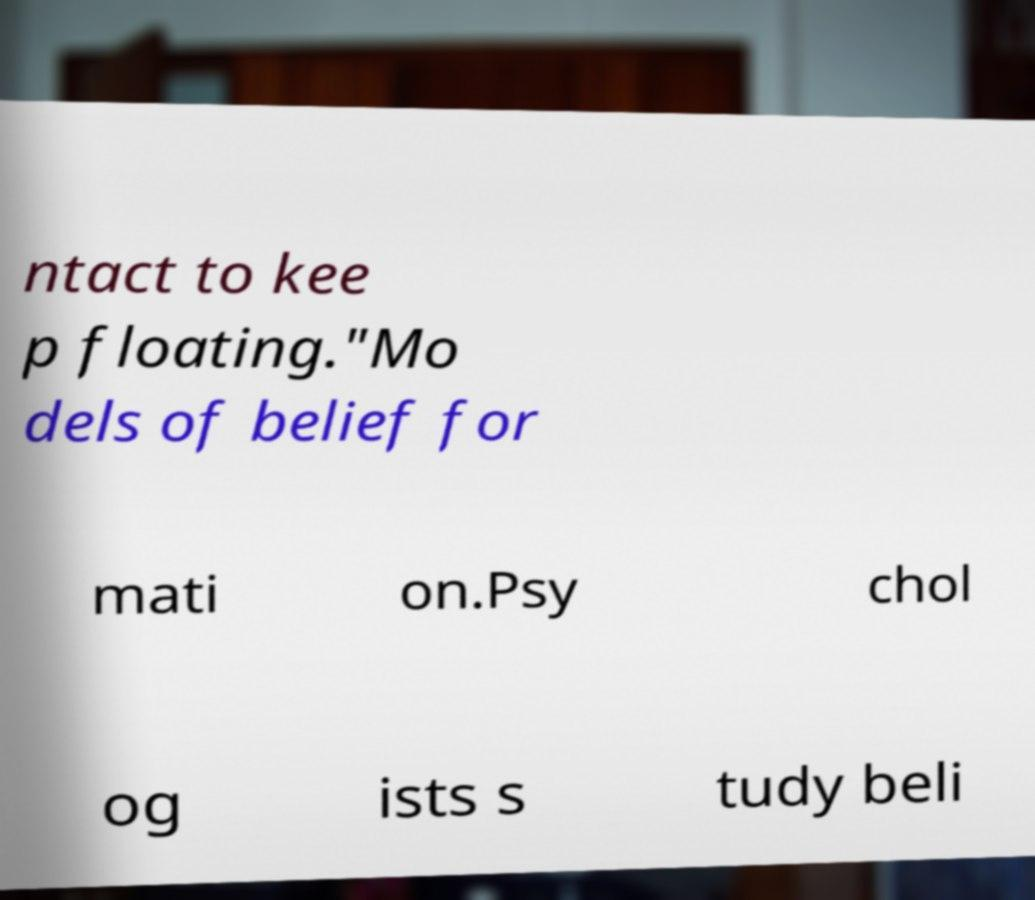For documentation purposes, I need the text within this image transcribed. Could you provide that? ntact to kee p floating."Mo dels of belief for mati on.Psy chol og ists s tudy beli 